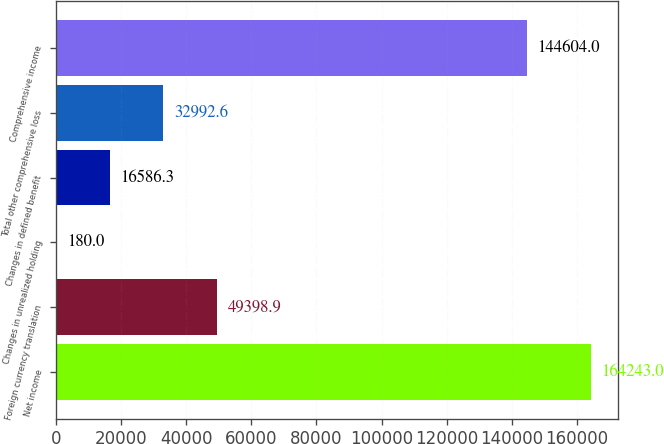<chart> <loc_0><loc_0><loc_500><loc_500><bar_chart><fcel>Net income<fcel>Foreign currency translation<fcel>Changes in unrealized holding<fcel>Changes in defined benefit<fcel>Total other comprehensive loss<fcel>Comprehensive income<nl><fcel>164243<fcel>49398.9<fcel>180<fcel>16586.3<fcel>32992.6<fcel>144604<nl></chart> 